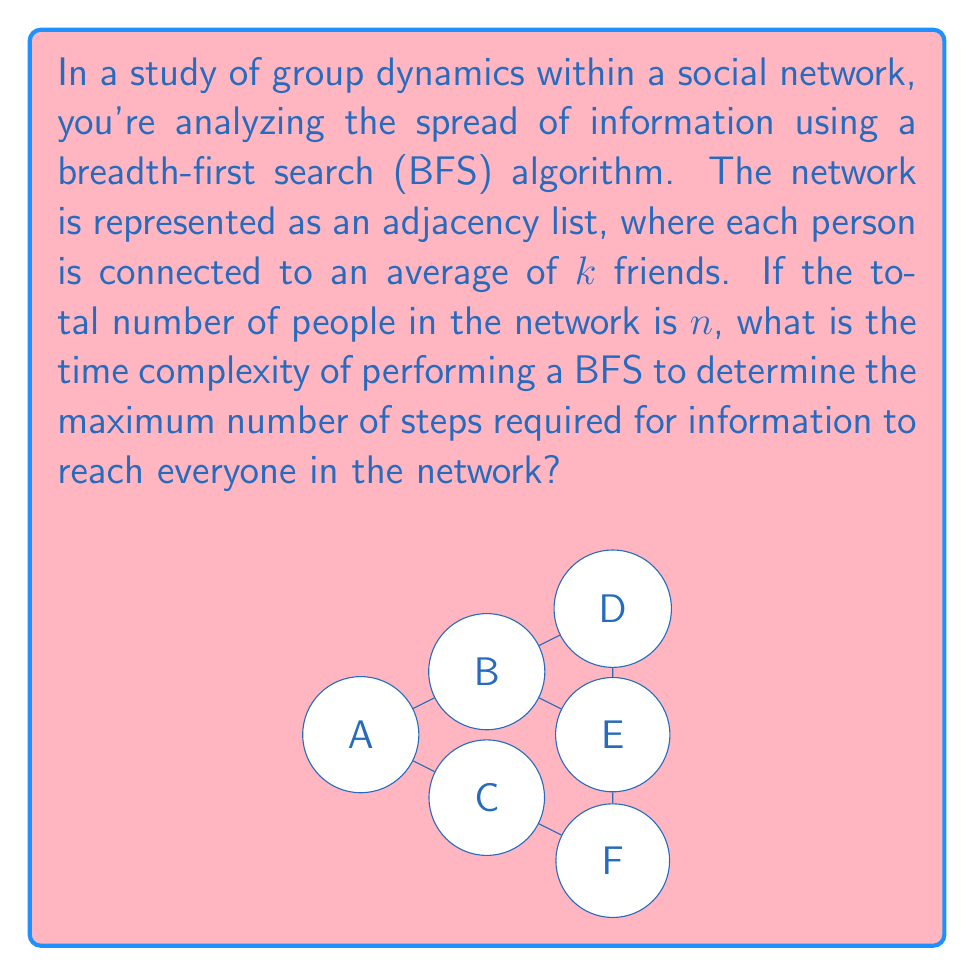What is the answer to this math problem? To analyze the time complexity of the BFS algorithm in this social network context, let's break it down step-by-step:

1) In a BFS, we visit each node (person) once and explore all of its neighbors.

2) For each person:
   - We dequeue them from the queue: $O(1)$
   - We check all of their friends (neighbors): $O(k)$ on average
   - For each unvisited friend, we mark them as visited and enqueue them: $O(1)$

3) The total operations for each person is therefore $O(1 + k + k) = O(k)$

4) We do this for all $n$ people in the network.

5) Therefore, the total time complexity is $O(n * k)$

6) However, in graph theory, we often express $k$ in terms of $n$. The total number of edges in the graph is $nk/2$ (divide by 2 because each edge is counted twice, once for each end).

7) In a connected graph, the number of edges is at least $n-1$, so:
   $nk/2 \geq n-1$
   $k \geq 2(1-1/n)$

8) This means $k = \Omega(1)$, or in other words, $k$ is at least a constant.

9) On the other hand, in a simple graph, $k < n$ always holds.

10) Combining these bounds: $\Omega(1) \leq k < n$

11) Therefore, we can express the time complexity as $O(n * min(k, n))$, which simplifies to $O(n^2)$ in the worst case.

This analysis shows that the time complexity is quadratic in the worst case, which occurs when the network is very densely connected (nearly everyone is friends with everyone else).
Answer: $O(n^2)$ 